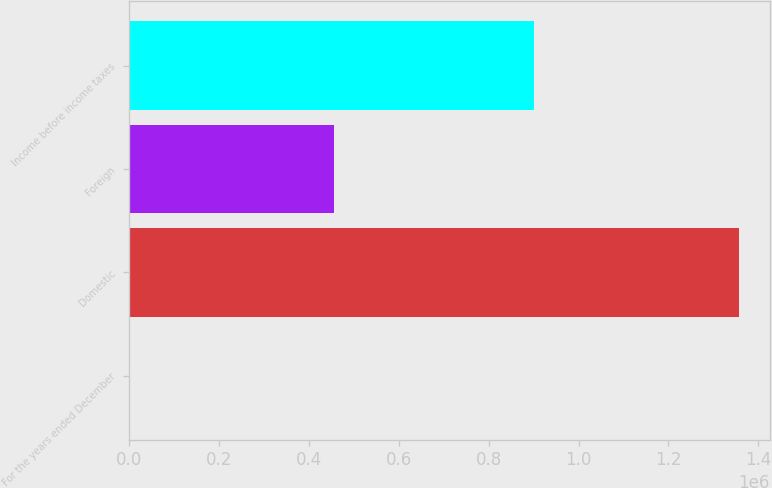Convert chart. <chart><loc_0><loc_0><loc_500><loc_500><bar_chart><fcel>For the years ended December<fcel>Domestic<fcel>Foreign<fcel>Income before income taxes<nl><fcel>2015<fcel>1.35762e+06<fcel>455771<fcel>901847<nl></chart> 